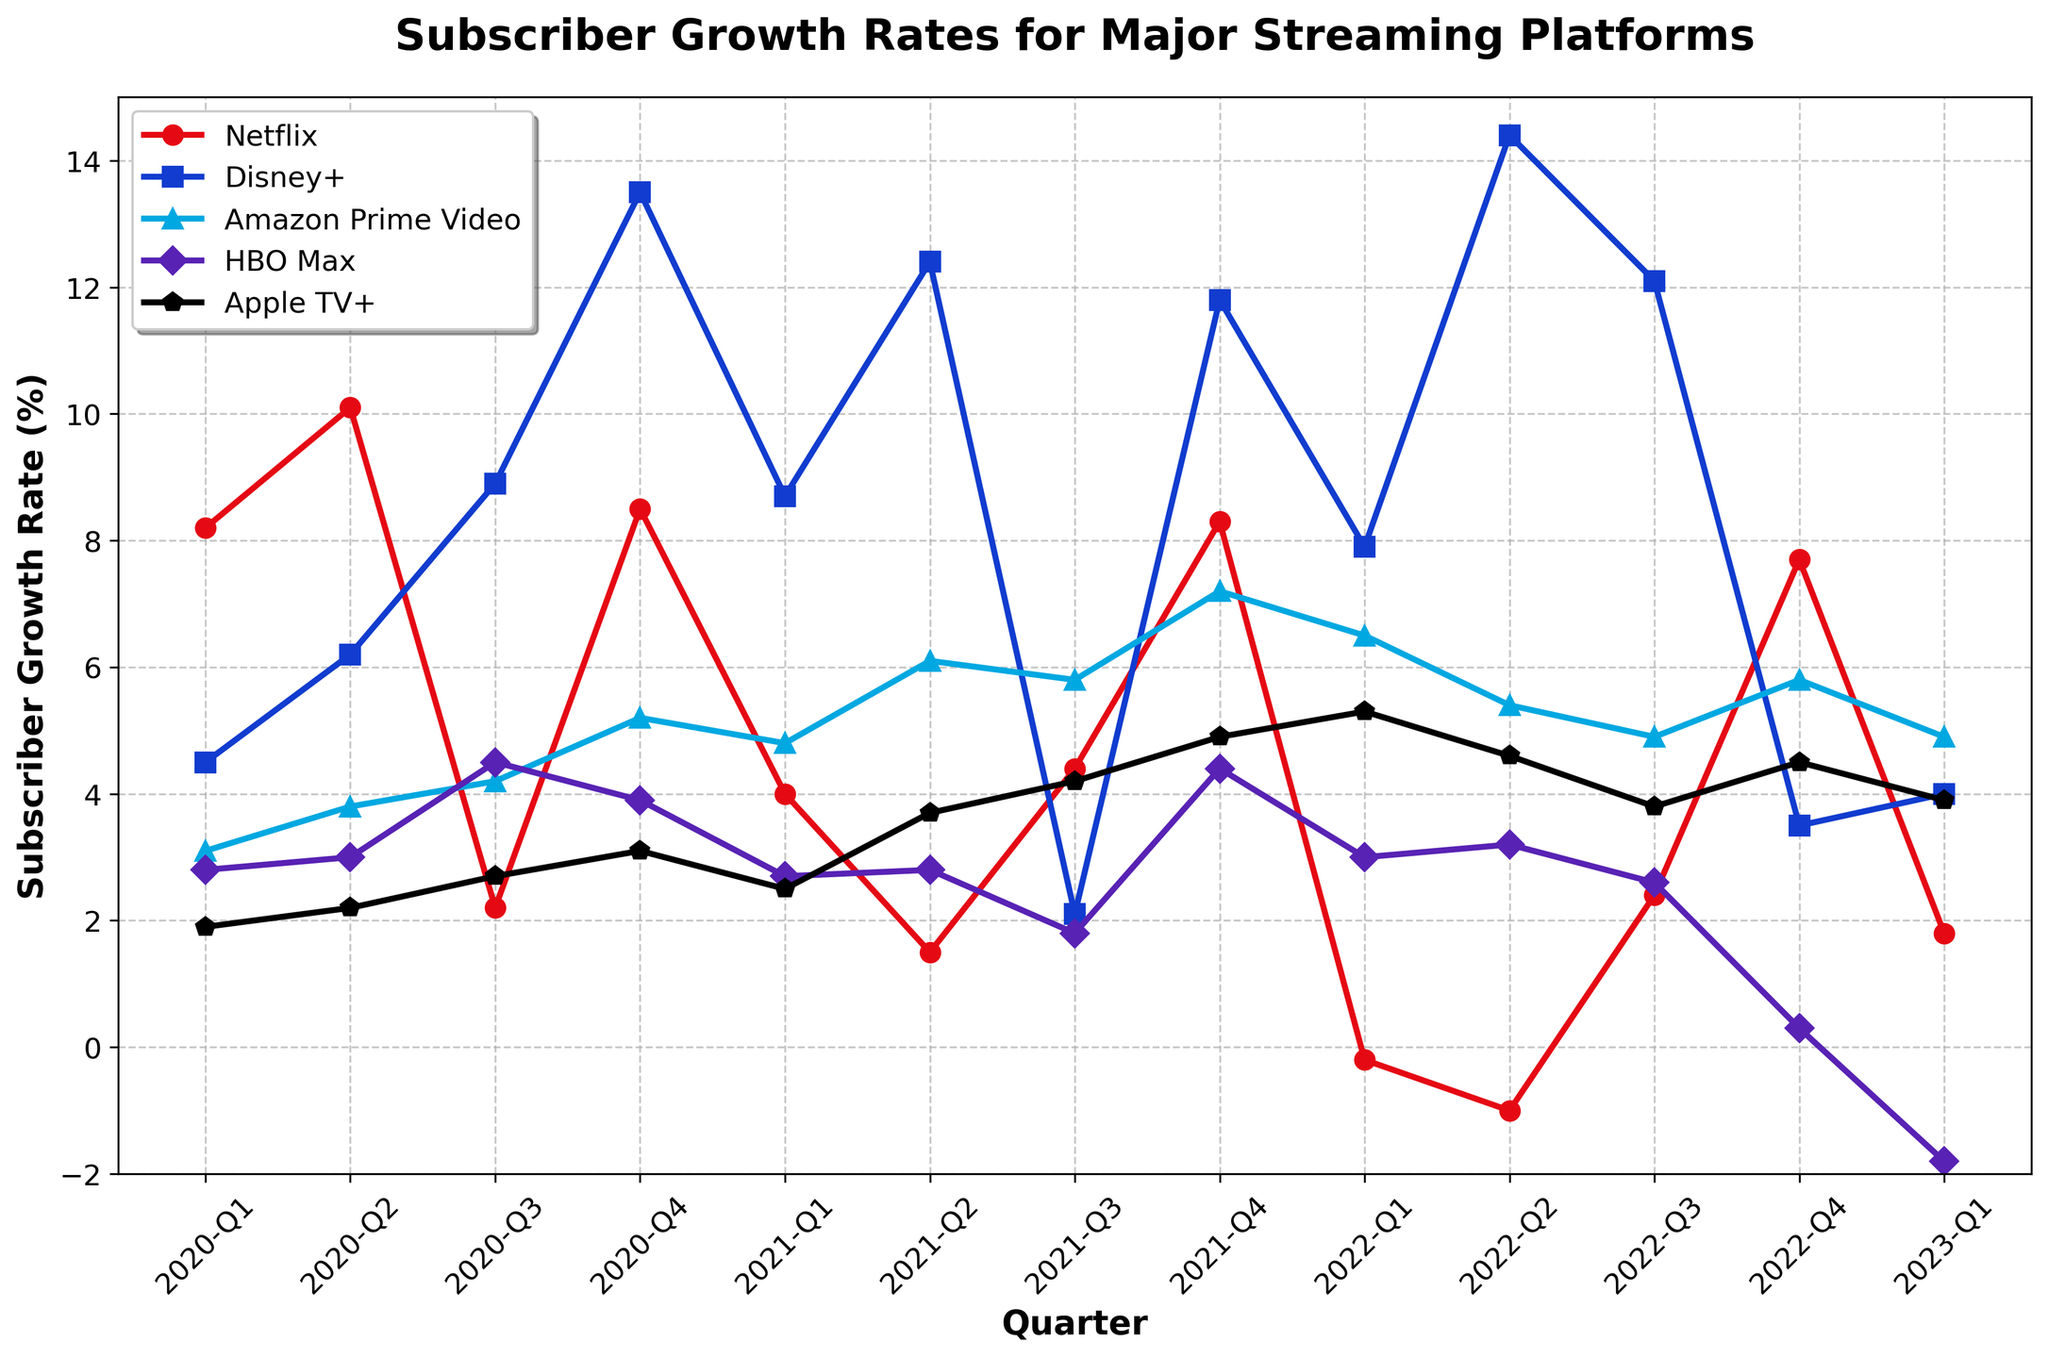What was Netflix's lowest subscriber growth rate, and in which quarter did it occur? The lowest subscriber growth rate for Netflix can be identified by scanning the line for the lowest point. We see that the lowest rate is -1.0% in 2022-Q2.
Answer: -1.0% in 2022-Q2 Between 2020-Q3 and 2021-Q3, which streaming service experienced the most significant increase in subscriber growth rate? By comparing the growth rates from 2020-Q3 and 2021-Q3 for all services, find the difference: Netflix (4.4 - 2.2 = 2.2), Disney+ (2.1 - 8.9 = -6.8), Amazon Prime Video (5.8 - 4.2 = 1.6), HBO Max (1.8 - 4.5 = -2.7), Apple TV+ (4.2 - 2.7 = 1.5). Disney+ had the largest net negative change, but Netflix had the most significant positive increase (2.2%).
Answer: Netflix Which streaming platform had the highest subscriber growth rate in 2021-Q4? Examine the line at the 2021-Q4 marker and compare the heights of each series: Netflix (8.3), Disney+ (11.8), Amazon Prime Video (7.2), HBO Max (4.4), Apple TV+ (4.9). Disney+ has the highest rate at 11.8%.
Answer: Disney+ For Apple TV+, which quarter saw the largest drop from the previous quarter? Look at the line for Apple TV+ and calculate the differences between each quarter: Q1-Q2 (-2.2-1.9=-0.3), Q2-Q3 (2.7-2.2=0.5), Q3-Q4 (3.1-2.7=0.4), Q4-Q1 (2.5-3.1=-0.6), Q1-Q2 (3.7-2.5=1.2), Q2-Q3 (4.2-3.7=0.5), Q3-Q4 (4.9-4.2=0.7), Q4-Q1 (5.3-4.9=0.4), Q1-Q2 (4.6-5.3=-0.7), Q2-Q3 (3.8-4.6=-0.8), Q3-Q4 (4.5-3.8=0.7), Q4-Q1 (3.9-4.5=-0.6). The largest drop was from 2020-Q4 to 2021-Q1, which is -0.6%.
Answer: 2020-Q4 to 2021-Q1 What is the overall trend for HBO Max's subscriber growth from 2020 to 2023? Observe the line for HBO Max from the start (2020-Q1) to the end (2023-Q1). The values rise until 2020-Q4 (3.9%), then mostly decline except for occasional rises (highest peak at 4.5% in 2020-Q3 and lowest -1.8% in 2023-Q1), showing an overall decreasing trend towards the end.
Answer: Decreasing trend Which quarter in 2022 showed the largest growth for Disney+? For Disney+ in 2022, compare the quarters: Q1 (7.9), Q2 (14.4), Q3 (12.1), Q4 (3.5). The largest growth is seen in 2022-Q2 at 14.4%.
Answer: 2022-Q2 